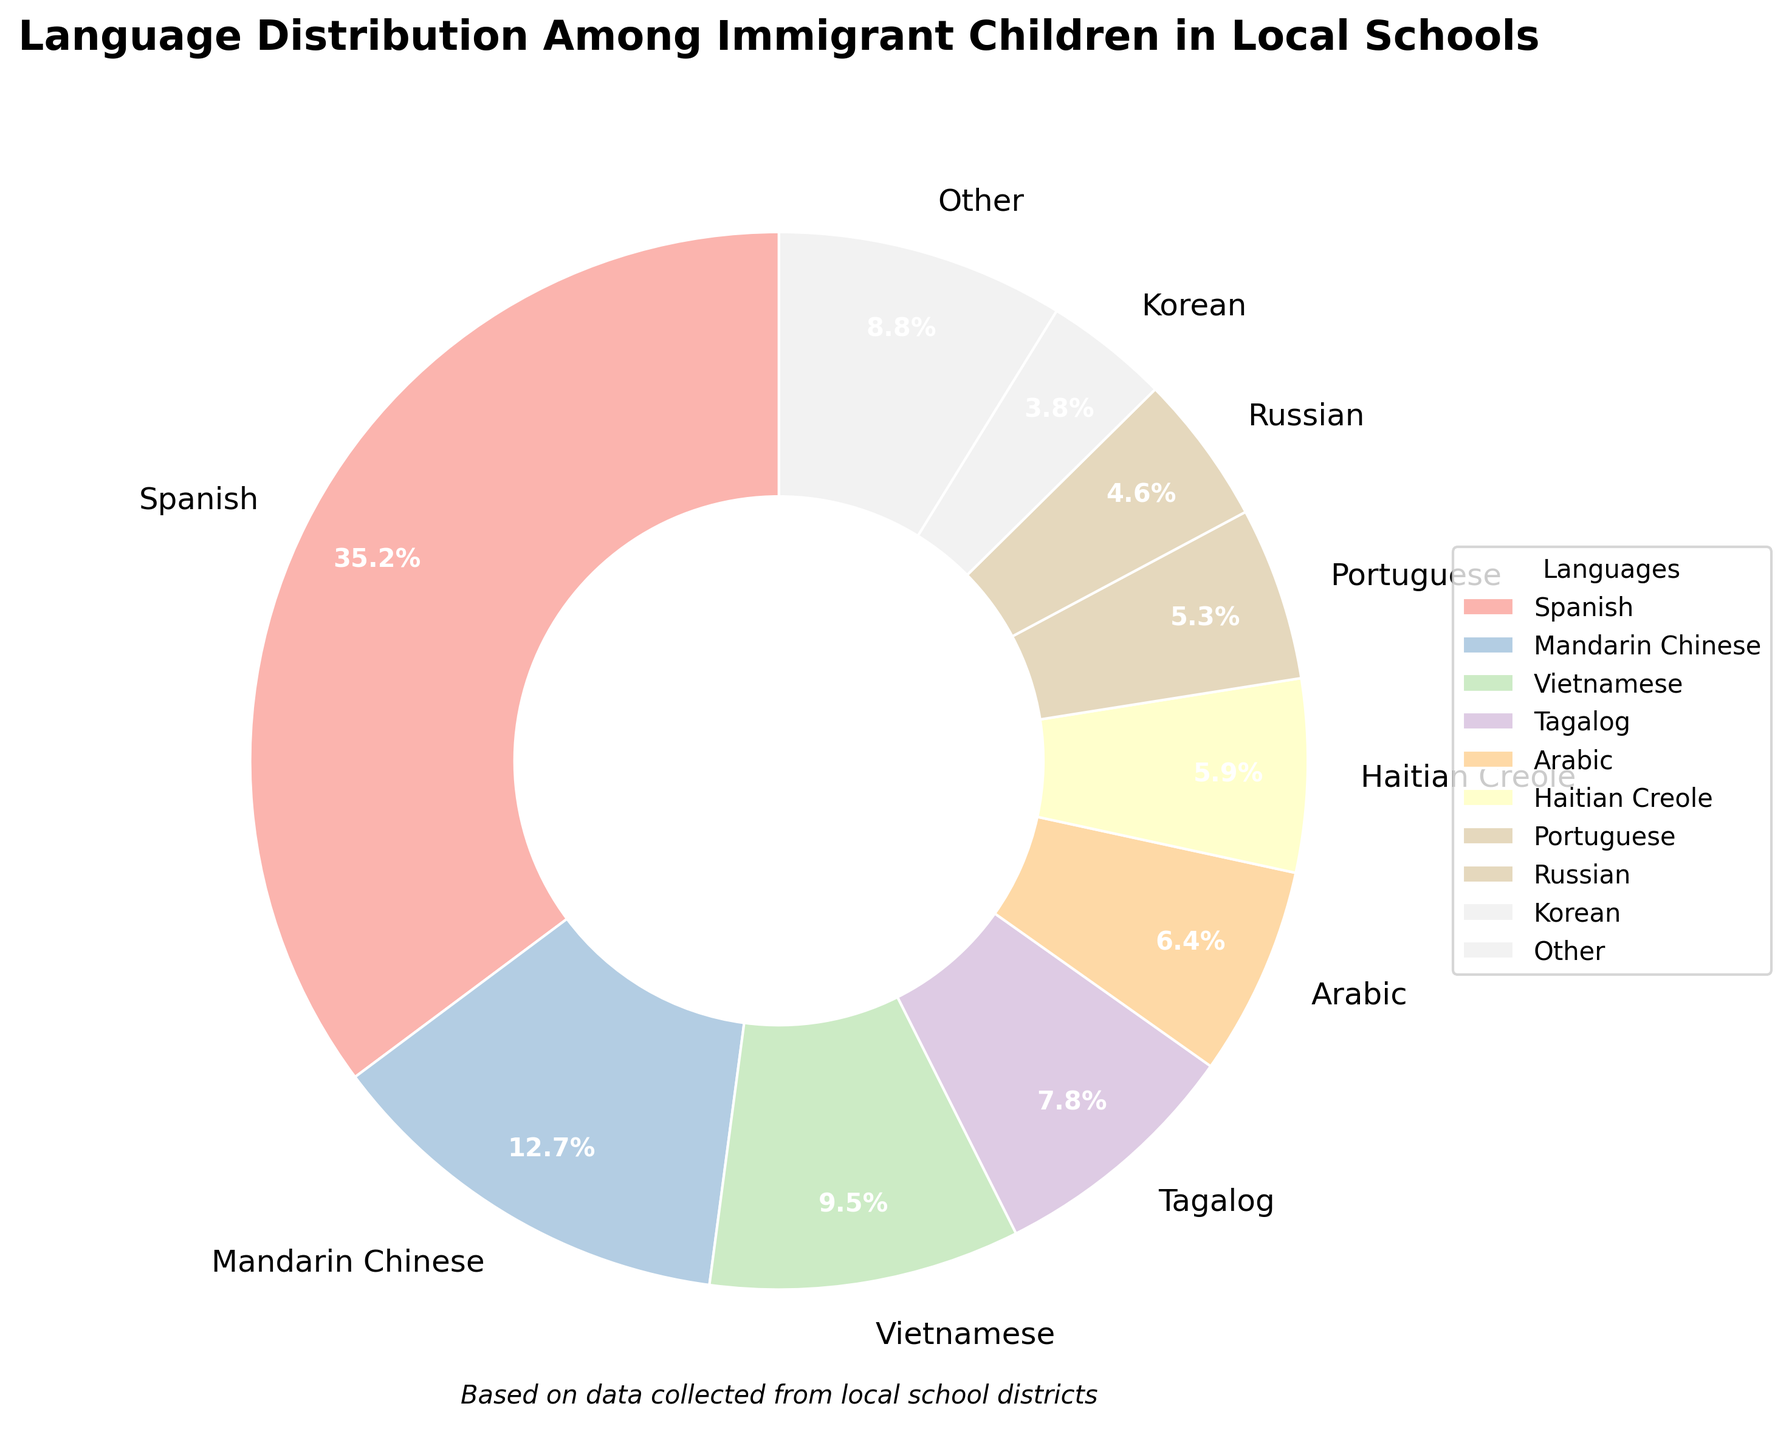What percentage of immigrant children speak Arabic? Locate the Arabic segment in the pie chart and read the percentage labeled next to it.
Answer: 6.4% Which language has the highest percentage among immigrant children? Identify the largest segment in the pie chart and read the language name labeled next to it.
Answer: Spanish How do the combined percentages of Vietnamese and Tagalog compare to that of Spanish? Find the percentages for Vietnamese (9.5%) and Tagalog (7.8%), sum them (9.5 + 7.8 = 17.3), then compare this sum to the percentage for Spanish (35.2%).
Answer: Lower What is the total percentage for languages that constitute less than 3% each? According to the plot, the "Other" category combines the percentages of languages each less than 3%. Read off the labeled percentage for the "Other" category from the pie chart.
Answer: 9.7% Which language segment is greater: Korean or Portuguese? Find the percentages for Korean (3.8%) and Portuguese (5.3%), then compare them.
Answer: Portuguese What is the difference in percentage between Haitian Creole and French-speaking children? Find the percentages for Haitian Creole (5.9%) and French (2.1%), and subtract the smaller from the larger (5.9 - 2.1).
Answer: 3.8% How many languages have a percentage greater than 5%? Count the number of pie chart segments labeled with percentages greater than 5%.
Answer: 6 Is the percentage of children speaking Russian higher or lower than those speaking Tagalog? Find the percentages for Russian (4.6%) and Tagalog (7.8%), then compare them.
Answer: Lower Of the languages listed, which one has the lowest percentage? Identify the smallest segment in the pie chart and read the language name labeled next to it.
Answer: Urdu What is the combined percentage of Mandarin Chinese, Arabic, and Portuguese-speaking children? Find the percentages for Mandarin Chinese (12.7%), Arabic (6.4%), and Portuguese (5.3%), and sum them (12.7 + 6.4 + 5.3 = 24.4).
Answer: 24.4% 